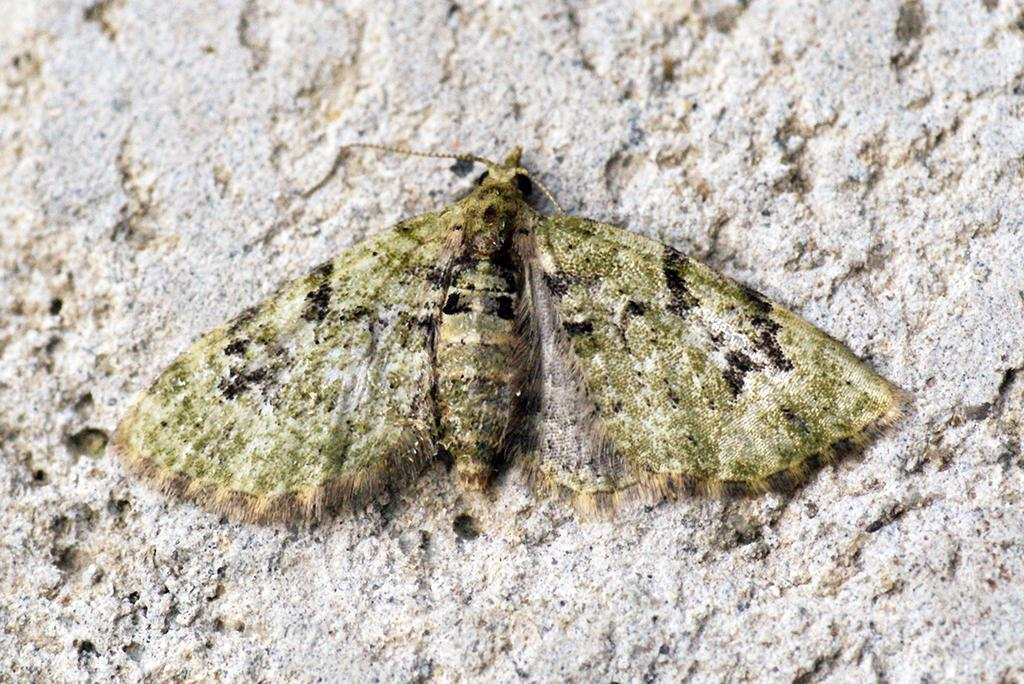What type of creature is in the picture? There is an insect in the picture. What are the main features of the insect? The insect has wings, a body, a head, and legs. What can be seen in the background of the picture? There is a rock in the backdrop of the picture. What type of frame surrounds the insect in the picture? There is no frame surrounding the insect in the picture; it is not a framed image. 